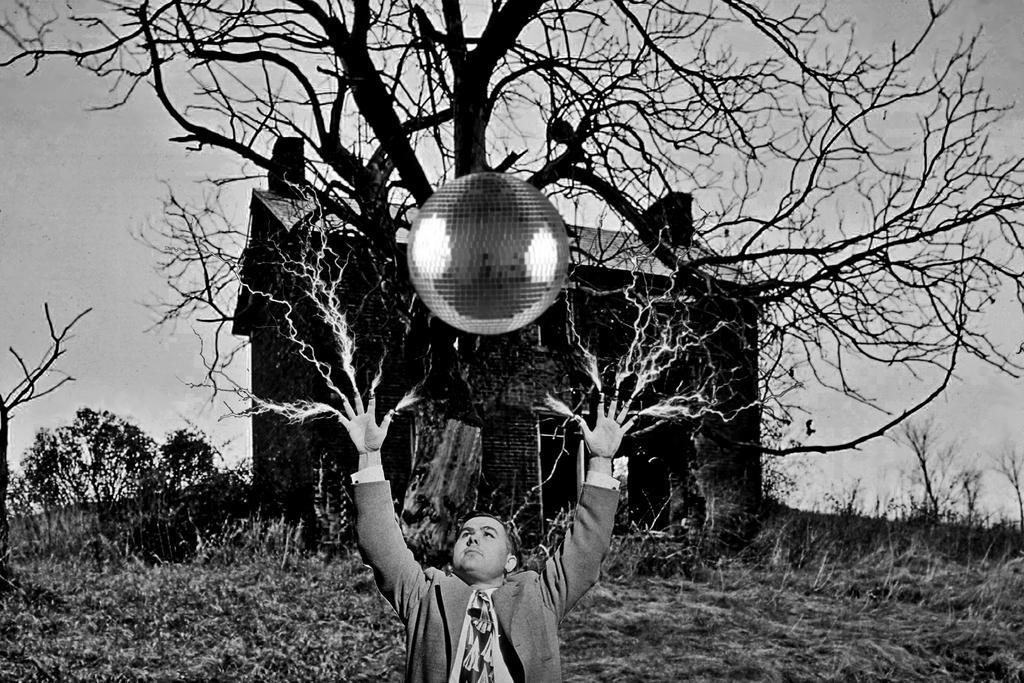Please provide a concise description of this image. This is a black and white image where we can see a person playing with ball, behind him there is a building, tree and plants. 